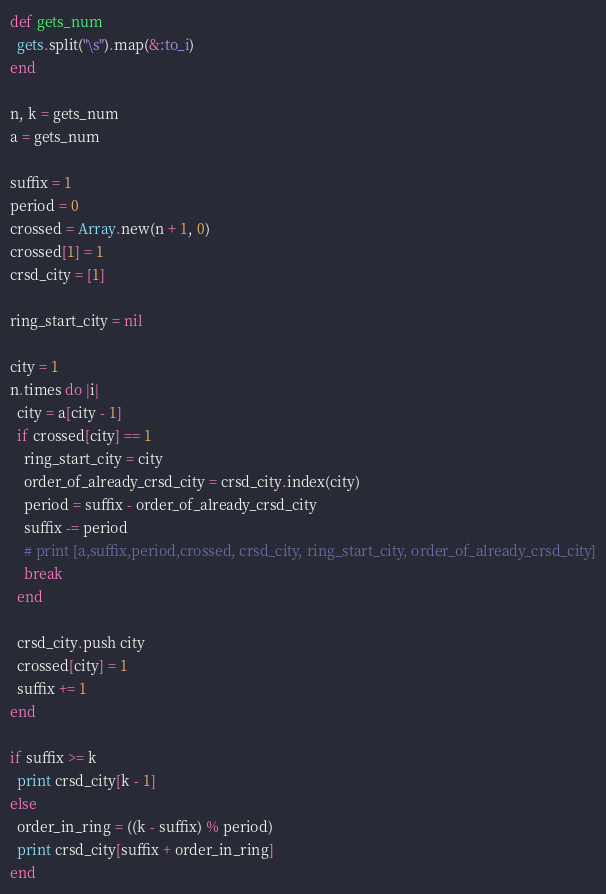Convert code to text. <code><loc_0><loc_0><loc_500><loc_500><_Ruby_>def gets_num
  gets.split("\s").map(&:to_i)
end

n, k = gets_num
a = gets_num

suffix = 1
period = 0
crossed = Array.new(n + 1, 0)
crossed[1] = 1
crsd_city = [1]

ring_start_city = nil

city = 1
n.times do |i|
  city = a[city - 1]
  if crossed[city] == 1
    ring_start_city = city
    order_of_already_crsd_city = crsd_city.index(city)
    period = suffix - order_of_already_crsd_city
    suffix -= period
    # print [a,suffix,period,crossed, crsd_city, ring_start_city, order_of_already_crsd_city]
    break
  end

  crsd_city.push city
  crossed[city] = 1
  suffix += 1
end

if suffix >= k
  print crsd_city[k - 1]
else
  order_in_ring = ((k - suffix) % period)
  print crsd_city[suffix + order_in_ring]
end</code> 